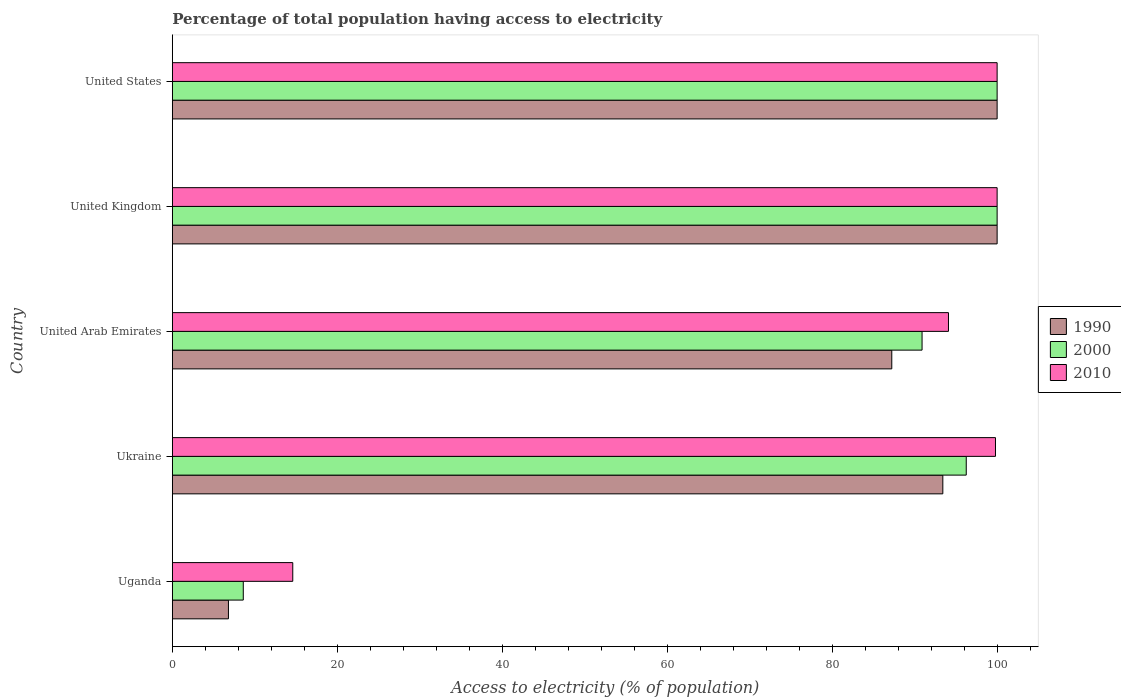How many different coloured bars are there?
Your response must be concise. 3. How many groups of bars are there?
Make the answer very short. 5. How many bars are there on the 5th tick from the top?
Give a very brief answer. 3. What is the label of the 5th group of bars from the top?
Give a very brief answer. Uganda. In how many cases, is the number of bars for a given country not equal to the number of legend labels?
Keep it short and to the point. 0. What is the percentage of population that have access to electricity in 2010 in United Arab Emirates?
Ensure brevity in your answer.  94.1. Across all countries, what is the maximum percentage of population that have access to electricity in 2010?
Give a very brief answer. 100. In which country was the percentage of population that have access to electricity in 1990 minimum?
Offer a very short reply. Uganda. What is the total percentage of population that have access to electricity in 1990 in the graph?
Your response must be concise. 387.44. What is the difference between the percentage of population that have access to electricity in 2010 in United Arab Emirates and that in United Kingdom?
Provide a short and direct response. -5.9. What is the difference between the percentage of population that have access to electricity in 2000 in Uganda and the percentage of population that have access to electricity in 2010 in United Kingdom?
Your answer should be compact. -91.4. What is the average percentage of population that have access to electricity in 1990 per country?
Your response must be concise. 77.49. What is the difference between the percentage of population that have access to electricity in 1990 and percentage of population that have access to electricity in 2000 in United Kingdom?
Your answer should be compact. 0. In how many countries, is the percentage of population that have access to electricity in 1990 greater than 28 %?
Provide a short and direct response. 4. What is the difference between the highest and the lowest percentage of population that have access to electricity in 1990?
Provide a succinct answer. 93.2. In how many countries, is the percentage of population that have access to electricity in 2010 greater than the average percentage of population that have access to electricity in 2010 taken over all countries?
Your answer should be compact. 4. What does the 1st bar from the top in United States represents?
Your answer should be compact. 2010. What does the 3rd bar from the bottom in Ukraine represents?
Offer a very short reply. 2010. How many bars are there?
Make the answer very short. 15. Does the graph contain any zero values?
Offer a terse response. No. Does the graph contain grids?
Provide a succinct answer. No. How many legend labels are there?
Make the answer very short. 3. How are the legend labels stacked?
Your answer should be compact. Vertical. What is the title of the graph?
Give a very brief answer. Percentage of total population having access to electricity. What is the label or title of the X-axis?
Your answer should be very brief. Access to electricity (% of population). What is the Access to electricity (% of population) in 2010 in Uganda?
Provide a short and direct response. 14.6. What is the Access to electricity (% of population) of 1990 in Ukraine?
Your answer should be very brief. 93.42. What is the Access to electricity (% of population) of 2000 in Ukraine?
Your answer should be very brief. 96.26. What is the Access to electricity (% of population) of 2010 in Ukraine?
Ensure brevity in your answer.  99.8. What is the Access to electricity (% of population) of 1990 in United Arab Emirates?
Ensure brevity in your answer.  87.23. What is the Access to electricity (% of population) in 2000 in United Arab Emirates?
Ensure brevity in your answer.  90.9. What is the Access to electricity (% of population) of 2010 in United Arab Emirates?
Give a very brief answer. 94.1. What is the Access to electricity (% of population) of 2000 in United States?
Your response must be concise. 100. What is the Access to electricity (% of population) in 2010 in United States?
Provide a short and direct response. 100. Across all countries, what is the maximum Access to electricity (% of population) in 1990?
Your answer should be very brief. 100. Across all countries, what is the minimum Access to electricity (% of population) of 1990?
Offer a very short reply. 6.8. Across all countries, what is the minimum Access to electricity (% of population) in 2000?
Offer a very short reply. 8.6. What is the total Access to electricity (% of population) of 1990 in the graph?
Your answer should be very brief. 387.44. What is the total Access to electricity (% of population) of 2000 in the graph?
Provide a succinct answer. 395.75. What is the total Access to electricity (% of population) in 2010 in the graph?
Your answer should be very brief. 408.5. What is the difference between the Access to electricity (% of population) of 1990 in Uganda and that in Ukraine?
Make the answer very short. -86.62. What is the difference between the Access to electricity (% of population) in 2000 in Uganda and that in Ukraine?
Offer a terse response. -87.66. What is the difference between the Access to electricity (% of population) of 2010 in Uganda and that in Ukraine?
Keep it short and to the point. -85.2. What is the difference between the Access to electricity (% of population) in 1990 in Uganda and that in United Arab Emirates?
Keep it short and to the point. -80.43. What is the difference between the Access to electricity (% of population) of 2000 in Uganda and that in United Arab Emirates?
Keep it short and to the point. -82.3. What is the difference between the Access to electricity (% of population) of 2010 in Uganda and that in United Arab Emirates?
Your response must be concise. -79.5. What is the difference between the Access to electricity (% of population) in 1990 in Uganda and that in United Kingdom?
Keep it short and to the point. -93.2. What is the difference between the Access to electricity (% of population) in 2000 in Uganda and that in United Kingdom?
Provide a succinct answer. -91.4. What is the difference between the Access to electricity (% of population) of 2010 in Uganda and that in United Kingdom?
Offer a terse response. -85.4. What is the difference between the Access to electricity (% of population) in 1990 in Uganda and that in United States?
Your response must be concise. -93.2. What is the difference between the Access to electricity (% of population) of 2000 in Uganda and that in United States?
Keep it short and to the point. -91.4. What is the difference between the Access to electricity (% of population) in 2010 in Uganda and that in United States?
Your response must be concise. -85.4. What is the difference between the Access to electricity (% of population) in 1990 in Ukraine and that in United Arab Emirates?
Your response must be concise. 6.19. What is the difference between the Access to electricity (% of population) in 2000 in Ukraine and that in United Arab Emirates?
Provide a succinct answer. 5.36. What is the difference between the Access to electricity (% of population) of 2010 in Ukraine and that in United Arab Emirates?
Give a very brief answer. 5.7. What is the difference between the Access to electricity (% of population) in 1990 in Ukraine and that in United Kingdom?
Your answer should be very brief. -6.58. What is the difference between the Access to electricity (% of population) of 2000 in Ukraine and that in United Kingdom?
Offer a terse response. -3.74. What is the difference between the Access to electricity (% of population) in 2010 in Ukraine and that in United Kingdom?
Offer a terse response. -0.2. What is the difference between the Access to electricity (% of population) of 1990 in Ukraine and that in United States?
Give a very brief answer. -6.58. What is the difference between the Access to electricity (% of population) of 2000 in Ukraine and that in United States?
Offer a terse response. -3.74. What is the difference between the Access to electricity (% of population) of 1990 in United Arab Emirates and that in United Kingdom?
Ensure brevity in your answer.  -12.77. What is the difference between the Access to electricity (% of population) in 2000 in United Arab Emirates and that in United Kingdom?
Provide a short and direct response. -9.1. What is the difference between the Access to electricity (% of population) of 2010 in United Arab Emirates and that in United Kingdom?
Your answer should be compact. -5.9. What is the difference between the Access to electricity (% of population) in 1990 in United Arab Emirates and that in United States?
Provide a short and direct response. -12.77. What is the difference between the Access to electricity (% of population) of 2000 in United Arab Emirates and that in United States?
Your answer should be compact. -9.1. What is the difference between the Access to electricity (% of population) in 1990 in United Kingdom and that in United States?
Give a very brief answer. 0. What is the difference between the Access to electricity (% of population) of 2000 in United Kingdom and that in United States?
Make the answer very short. 0. What is the difference between the Access to electricity (% of population) in 2010 in United Kingdom and that in United States?
Your answer should be very brief. 0. What is the difference between the Access to electricity (% of population) in 1990 in Uganda and the Access to electricity (% of population) in 2000 in Ukraine?
Your response must be concise. -89.46. What is the difference between the Access to electricity (% of population) of 1990 in Uganda and the Access to electricity (% of population) of 2010 in Ukraine?
Make the answer very short. -93. What is the difference between the Access to electricity (% of population) in 2000 in Uganda and the Access to electricity (% of population) in 2010 in Ukraine?
Your answer should be compact. -91.2. What is the difference between the Access to electricity (% of population) of 1990 in Uganda and the Access to electricity (% of population) of 2000 in United Arab Emirates?
Your answer should be very brief. -84.1. What is the difference between the Access to electricity (% of population) in 1990 in Uganda and the Access to electricity (% of population) in 2010 in United Arab Emirates?
Provide a succinct answer. -87.3. What is the difference between the Access to electricity (% of population) in 2000 in Uganda and the Access to electricity (% of population) in 2010 in United Arab Emirates?
Offer a very short reply. -85.5. What is the difference between the Access to electricity (% of population) of 1990 in Uganda and the Access to electricity (% of population) of 2000 in United Kingdom?
Give a very brief answer. -93.2. What is the difference between the Access to electricity (% of population) of 1990 in Uganda and the Access to electricity (% of population) of 2010 in United Kingdom?
Your response must be concise. -93.2. What is the difference between the Access to electricity (% of population) in 2000 in Uganda and the Access to electricity (% of population) in 2010 in United Kingdom?
Your response must be concise. -91.4. What is the difference between the Access to electricity (% of population) of 1990 in Uganda and the Access to electricity (% of population) of 2000 in United States?
Give a very brief answer. -93.2. What is the difference between the Access to electricity (% of population) of 1990 in Uganda and the Access to electricity (% of population) of 2010 in United States?
Provide a succinct answer. -93.2. What is the difference between the Access to electricity (% of population) of 2000 in Uganda and the Access to electricity (% of population) of 2010 in United States?
Provide a short and direct response. -91.4. What is the difference between the Access to electricity (% of population) of 1990 in Ukraine and the Access to electricity (% of population) of 2000 in United Arab Emirates?
Provide a succinct answer. 2.52. What is the difference between the Access to electricity (% of population) of 1990 in Ukraine and the Access to electricity (% of population) of 2010 in United Arab Emirates?
Offer a very short reply. -0.68. What is the difference between the Access to electricity (% of population) in 2000 in Ukraine and the Access to electricity (% of population) in 2010 in United Arab Emirates?
Provide a succinct answer. 2.16. What is the difference between the Access to electricity (% of population) in 1990 in Ukraine and the Access to electricity (% of population) in 2000 in United Kingdom?
Your answer should be very brief. -6.58. What is the difference between the Access to electricity (% of population) in 1990 in Ukraine and the Access to electricity (% of population) in 2010 in United Kingdom?
Your answer should be very brief. -6.58. What is the difference between the Access to electricity (% of population) of 2000 in Ukraine and the Access to electricity (% of population) of 2010 in United Kingdom?
Provide a short and direct response. -3.74. What is the difference between the Access to electricity (% of population) in 1990 in Ukraine and the Access to electricity (% of population) in 2000 in United States?
Provide a succinct answer. -6.58. What is the difference between the Access to electricity (% of population) of 1990 in Ukraine and the Access to electricity (% of population) of 2010 in United States?
Offer a very short reply. -6.58. What is the difference between the Access to electricity (% of population) of 2000 in Ukraine and the Access to electricity (% of population) of 2010 in United States?
Your answer should be compact. -3.74. What is the difference between the Access to electricity (% of population) of 1990 in United Arab Emirates and the Access to electricity (% of population) of 2000 in United Kingdom?
Give a very brief answer. -12.77. What is the difference between the Access to electricity (% of population) of 1990 in United Arab Emirates and the Access to electricity (% of population) of 2010 in United Kingdom?
Provide a succinct answer. -12.77. What is the difference between the Access to electricity (% of population) of 2000 in United Arab Emirates and the Access to electricity (% of population) of 2010 in United Kingdom?
Your answer should be very brief. -9.1. What is the difference between the Access to electricity (% of population) in 1990 in United Arab Emirates and the Access to electricity (% of population) in 2000 in United States?
Ensure brevity in your answer.  -12.77. What is the difference between the Access to electricity (% of population) of 1990 in United Arab Emirates and the Access to electricity (% of population) of 2010 in United States?
Ensure brevity in your answer.  -12.77. What is the difference between the Access to electricity (% of population) of 2000 in United Arab Emirates and the Access to electricity (% of population) of 2010 in United States?
Your answer should be compact. -9.1. What is the difference between the Access to electricity (% of population) in 1990 in United Kingdom and the Access to electricity (% of population) in 2000 in United States?
Your response must be concise. 0. What is the difference between the Access to electricity (% of population) in 1990 in United Kingdom and the Access to electricity (% of population) in 2010 in United States?
Give a very brief answer. 0. What is the difference between the Access to electricity (% of population) in 2000 in United Kingdom and the Access to electricity (% of population) in 2010 in United States?
Make the answer very short. 0. What is the average Access to electricity (% of population) in 1990 per country?
Offer a very short reply. 77.49. What is the average Access to electricity (% of population) of 2000 per country?
Provide a succinct answer. 79.15. What is the average Access to electricity (% of population) in 2010 per country?
Make the answer very short. 81.7. What is the difference between the Access to electricity (% of population) in 2000 and Access to electricity (% of population) in 2010 in Uganda?
Offer a terse response. -6. What is the difference between the Access to electricity (% of population) of 1990 and Access to electricity (% of population) of 2000 in Ukraine?
Make the answer very short. -2.84. What is the difference between the Access to electricity (% of population) in 1990 and Access to electricity (% of population) in 2010 in Ukraine?
Your answer should be very brief. -6.38. What is the difference between the Access to electricity (% of population) of 2000 and Access to electricity (% of population) of 2010 in Ukraine?
Ensure brevity in your answer.  -3.54. What is the difference between the Access to electricity (% of population) of 1990 and Access to electricity (% of population) of 2000 in United Arab Emirates?
Provide a succinct answer. -3.67. What is the difference between the Access to electricity (% of population) of 1990 and Access to electricity (% of population) of 2010 in United Arab Emirates?
Provide a short and direct response. -6.87. What is the difference between the Access to electricity (% of population) of 2000 and Access to electricity (% of population) of 2010 in United Arab Emirates?
Provide a succinct answer. -3.2. What is the difference between the Access to electricity (% of population) in 2000 and Access to electricity (% of population) in 2010 in United Kingdom?
Offer a terse response. 0. What is the difference between the Access to electricity (% of population) in 1990 and Access to electricity (% of population) in 2000 in United States?
Give a very brief answer. 0. What is the difference between the Access to electricity (% of population) in 2000 and Access to electricity (% of population) in 2010 in United States?
Your answer should be compact. 0. What is the ratio of the Access to electricity (% of population) in 1990 in Uganda to that in Ukraine?
Keep it short and to the point. 0.07. What is the ratio of the Access to electricity (% of population) in 2000 in Uganda to that in Ukraine?
Ensure brevity in your answer.  0.09. What is the ratio of the Access to electricity (% of population) of 2010 in Uganda to that in Ukraine?
Keep it short and to the point. 0.15. What is the ratio of the Access to electricity (% of population) in 1990 in Uganda to that in United Arab Emirates?
Ensure brevity in your answer.  0.08. What is the ratio of the Access to electricity (% of population) of 2000 in Uganda to that in United Arab Emirates?
Make the answer very short. 0.09. What is the ratio of the Access to electricity (% of population) of 2010 in Uganda to that in United Arab Emirates?
Provide a short and direct response. 0.16. What is the ratio of the Access to electricity (% of population) of 1990 in Uganda to that in United Kingdom?
Provide a succinct answer. 0.07. What is the ratio of the Access to electricity (% of population) in 2000 in Uganda to that in United Kingdom?
Give a very brief answer. 0.09. What is the ratio of the Access to electricity (% of population) in 2010 in Uganda to that in United Kingdom?
Offer a very short reply. 0.15. What is the ratio of the Access to electricity (% of population) of 1990 in Uganda to that in United States?
Keep it short and to the point. 0.07. What is the ratio of the Access to electricity (% of population) of 2000 in Uganda to that in United States?
Ensure brevity in your answer.  0.09. What is the ratio of the Access to electricity (% of population) in 2010 in Uganda to that in United States?
Your response must be concise. 0.15. What is the ratio of the Access to electricity (% of population) in 1990 in Ukraine to that in United Arab Emirates?
Your answer should be compact. 1.07. What is the ratio of the Access to electricity (% of population) in 2000 in Ukraine to that in United Arab Emirates?
Give a very brief answer. 1.06. What is the ratio of the Access to electricity (% of population) of 2010 in Ukraine to that in United Arab Emirates?
Provide a short and direct response. 1.06. What is the ratio of the Access to electricity (% of population) of 1990 in Ukraine to that in United Kingdom?
Your answer should be very brief. 0.93. What is the ratio of the Access to electricity (% of population) of 2000 in Ukraine to that in United Kingdom?
Keep it short and to the point. 0.96. What is the ratio of the Access to electricity (% of population) in 1990 in Ukraine to that in United States?
Keep it short and to the point. 0.93. What is the ratio of the Access to electricity (% of population) in 2000 in Ukraine to that in United States?
Your answer should be very brief. 0.96. What is the ratio of the Access to electricity (% of population) of 2010 in Ukraine to that in United States?
Your response must be concise. 1. What is the ratio of the Access to electricity (% of population) in 1990 in United Arab Emirates to that in United Kingdom?
Your answer should be very brief. 0.87. What is the ratio of the Access to electricity (% of population) in 2000 in United Arab Emirates to that in United Kingdom?
Your response must be concise. 0.91. What is the ratio of the Access to electricity (% of population) in 2010 in United Arab Emirates to that in United Kingdom?
Your answer should be very brief. 0.94. What is the ratio of the Access to electricity (% of population) in 1990 in United Arab Emirates to that in United States?
Your answer should be very brief. 0.87. What is the ratio of the Access to electricity (% of population) in 2000 in United Arab Emirates to that in United States?
Your answer should be very brief. 0.91. What is the ratio of the Access to electricity (% of population) in 2010 in United Arab Emirates to that in United States?
Your response must be concise. 0.94. What is the ratio of the Access to electricity (% of population) of 1990 in United Kingdom to that in United States?
Keep it short and to the point. 1. What is the ratio of the Access to electricity (% of population) of 2010 in United Kingdom to that in United States?
Your answer should be very brief. 1. What is the difference between the highest and the second highest Access to electricity (% of population) in 1990?
Keep it short and to the point. 0. What is the difference between the highest and the second highest Access to electricity (% of population) of 2000?
Your answer should be very brief. 0. What is the difference between the highest and the second highest Access to electricity (% of population) in 2010?
Your response must be concise. 0. What is the difference between the highest and the lowest Access to electricity (% of population) of 1990?
Keep it short and to the point. 93.2. What is the difference between the highest and the lowest Access to electricity (% of population) of 2000?
Provide a short and direct response. 91.4. What is the difference between the highest and the lowest Access to electricity (% of population) of 2010?
Ensure brevity in your answer.  85.4. 